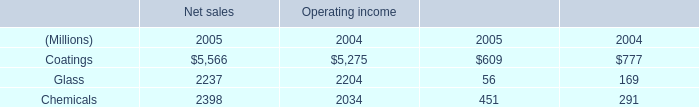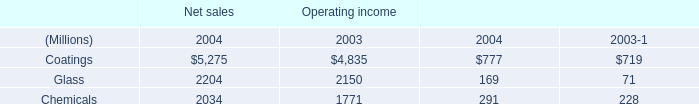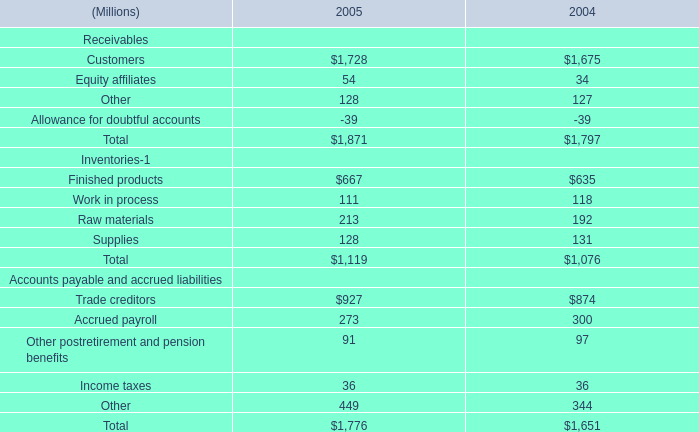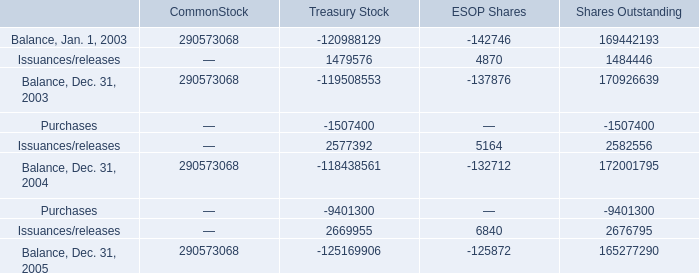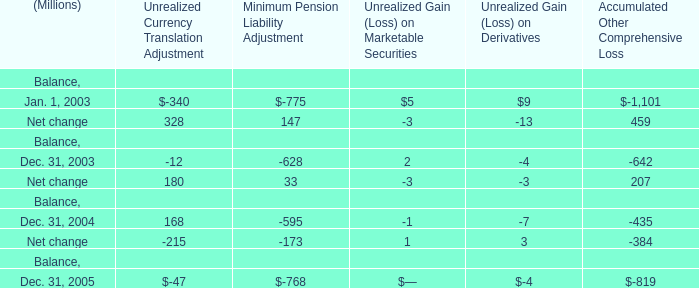What is the average amount of Coatings of Operating income 2004, and Issuances/releases of Shares Outstanding ? 
Computations: ((5275.0 + 2676795.0) / 2)
Answer: 1341035.0. 